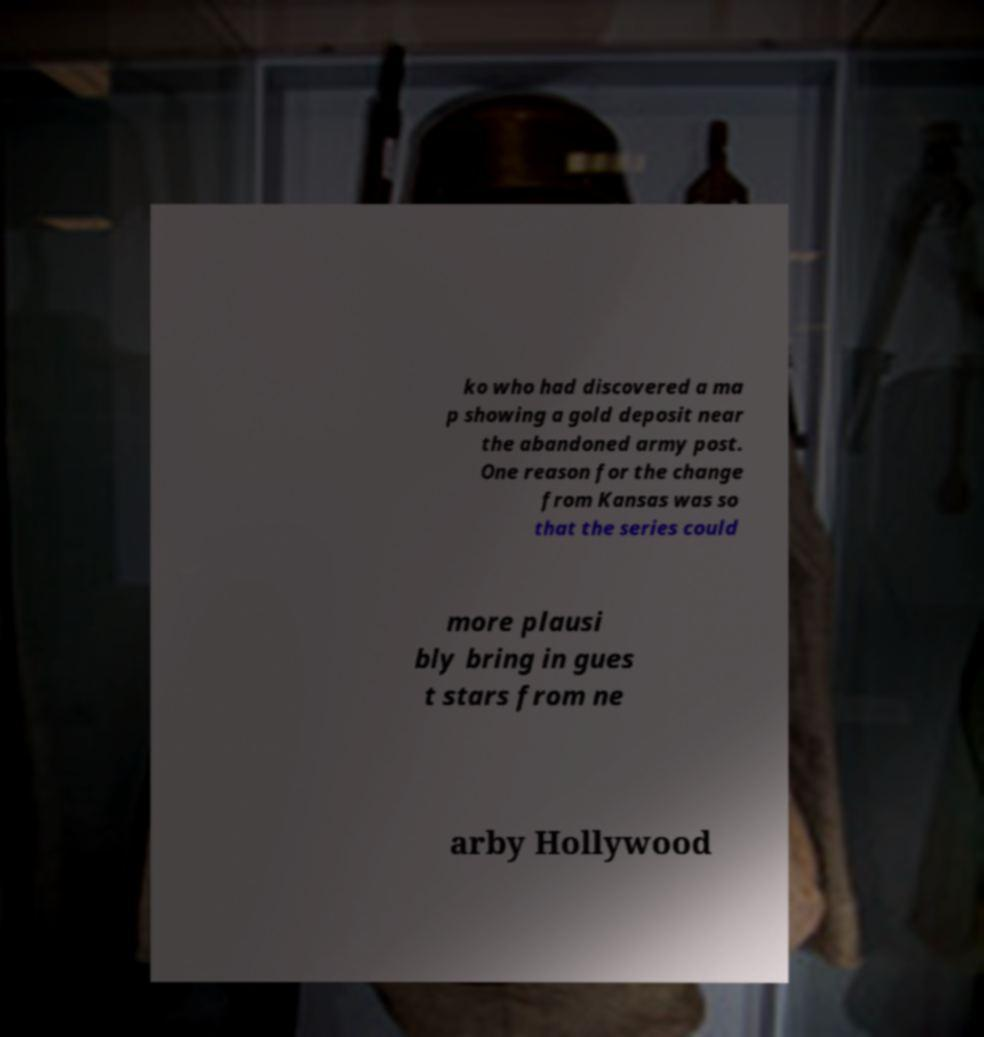Could you extract and type out the text from this image? ko who had discovered a ma p showing a gold deposit near the abandoned army post. One reason for the change from Kansas was so that the series could more plausi bly bring in gues t stars from ne arby Hollywood 